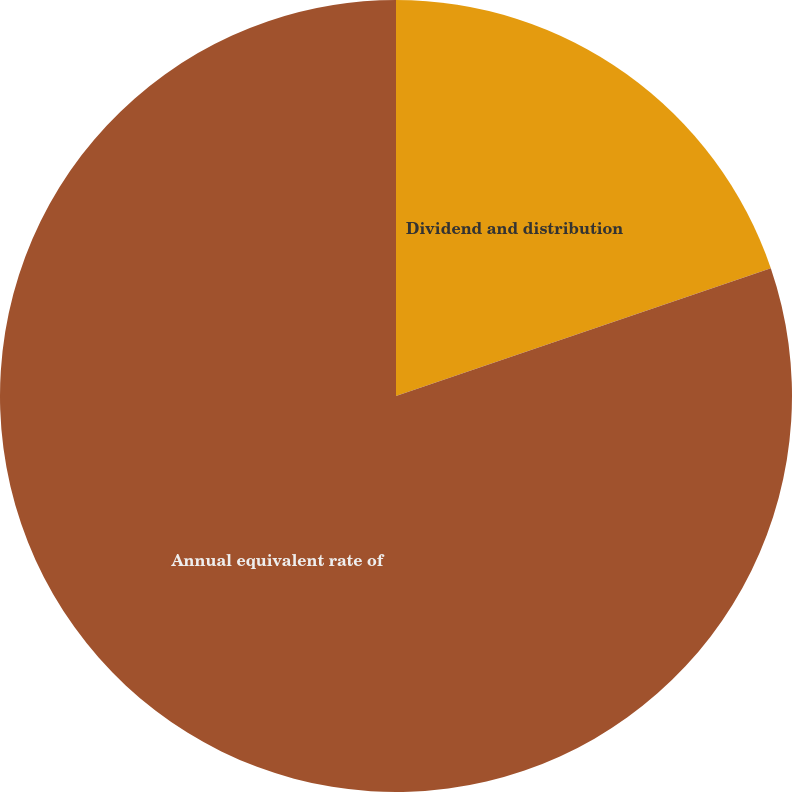<chart> <loc_0><loc_0><loc_500><loc_500><pie_chart><fcel>Dividend and distribution<fcel>Annual equivalent rate of<nl><fcel>19.77%<fcel>80.23%<nl></chart> 